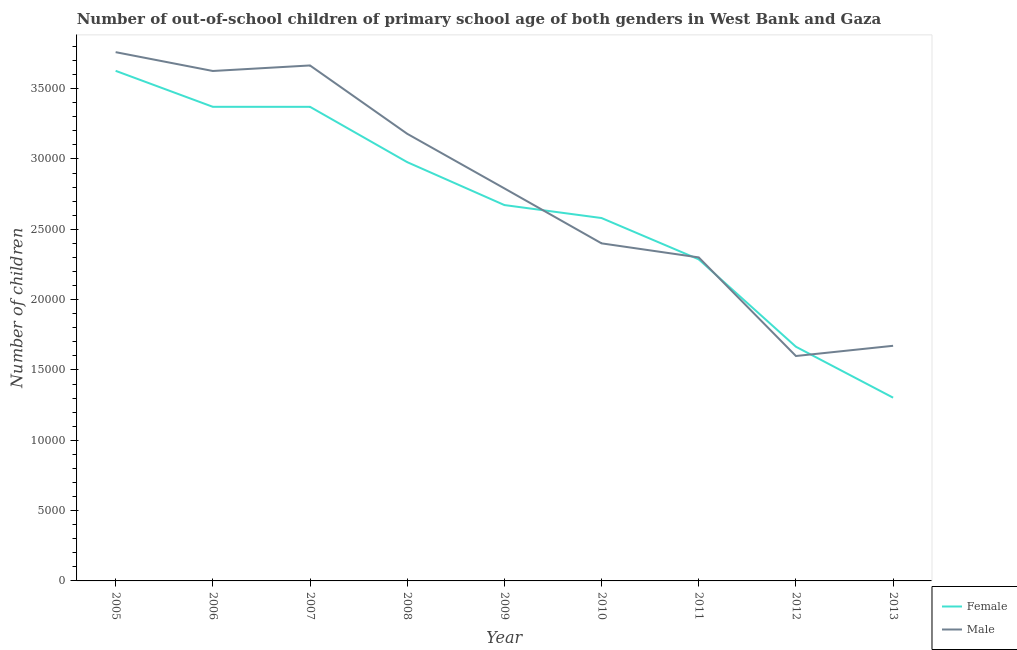How many different coloured lines are there?
Offer a very short reply. 2. Does the line corresponding to number of female out-of-school students intersect with the line corresponding to number of male out-of-school students?
Make the answer very short. Yes. Is the number of lines equal to the number of legend labels?
Provide a succinct answer. Yes. What is the number of female out-of-school students in 2006?
Provide a succinct answer. 3.37e+04. Across all years, what is the maximum number of male out-of-school students?
Give a very brief answer. 3.76e+04. Across all years, what is the minimum number of female out-of-school students?
Offer a terse response. 1.30e+04. In which year was the number of male out-of-school students minimum?
Ensure brevity in your answer.  2012. What is the total number of female out-of-school students in the graph?
Your answer should be very brief. 2.39e+05. What is the difference between the number of female out-of-school students in 2011 and that in 2013?
Provide a succinct answer. 9834. What is the difference between the number of female out-of-school students in 2006 and the number of male out-of-school students in 2013?
Ensure brevity in your answer.  1.70e+04. What is the average number of male out-of-school students per year?
Offer a terse response. 2.78e+04. In the year 2013, what is the difference between the number of female out-of-school students and number of male out-of-school students?
Offer a terse response. -3689. What is the ratio of the number of female out-of-school students in 2006 to that in 2010?
Provide a short and direct response. 1.31. Is the number of female out-of-school students in 2006 less than that in 2008?
Offer a very short reply. No. Is the difference between the number of female out-of-school students in 2007 and 2010 greater than the difference between the number of male out-of-school students in 2007 and 2010?
Give a very brief answer. No. What is the difference between the highest and the second highest number of male out-of-school students?
Keep it short and to the point. 946. What is the difference between the highest and the lowest number of male out-of-school students?
Your answer should be very brief. 2.16e+04. Is the sum of the number of female out-of-school students in 2007 and 2010 greater than the maximum number of male out-of-school students across all years?
Offer a very short reply. Yes. Does the number of female out-of-school students monotonically increase over the years?
Make the answer very short. No. How many years are there in the graph?
Your response must be concise. 9. What is the difference between two consecutive major ticks on the Y-axis?
Offer a terse response. 5000. Where does the legend appear in the graph?
Offer a terse response. Bottom right. How are the legend labels stacked?
Make the answer very short. Vertical. What is the title of the graph?
Give a very brief answer. Number of out-of-school children of primary school age of both genders in West Bank and Gaza. What is the label or title of the X-axis?
Give a very brief answer. Year. What is the label or title of the Y-axis?
Ensure brevity in your answer.  Number of children. What is the Number of children in Female in 2005?
Make the answer very short. 3.63e+04. What is the Number of children of Male in 2005?
Offer a very short reply. 3.76e+04. What is the Number of children of Female in 2006?
Keep it short and to the point. 3.37e+04. What is the Number of children in Male in 2006?
Ensure brevity in your answer.  3.63e+04. What is the Number of children in Female in 2007?
Make the answer very short. 3.37e+04. What is the Number of children in Male in 2007?
Provide a succinct answer. 3.66e+04. What is the Number of children in Female in 2008?
Your response must be concise. 2.98e+04. What is the Number of children of Male in 2008?
Provide a succinct answer. 3.18e+04. What is the Number of children of Female in 2009?
Your answer should be very brief. 2.67e+04. What is the Number of children in Male in 2009?
Offer a terse response. 2.79e+04. What is the Number of children in Female in 2010?
Your answer should be very brief. 2.58e+04. What is the Number of children of Male in 2010?
Keep it short and to the point. 2.40e+04. What is the Number of children of Female in 2011?
Your answer should be very brief. 2.29e+04. What is the Number of children in Male in 2011?
Ensure brevity in your answer.  2.30e+04. What is the Number of children of Female in 2012?
Your answer should be very brief. 1.66e+04. What is the Number of children in Male in 2012?
Provide a succinct answer. 1.60e+04. What is the Number of children of Female in 2013?
Your answer should be very brief. 1.30e+04. What is the Number of children in Male in 2013?
Offer a very short reply. 1.67e+04. Across all years, what is the maximum Number of children of Female?
Give a very brief answer. 3.63e+04. Across all years, what is the maximum Number of children of Male?
Provide a succinct answer. 3.76e+04. Across all years, what is the minimum Number of children in Female?
Offer a terse response. 1.30e+04. Across all years, what is the minimum Number of children of Male?
Offer a terse response. 1.60e+04. What is the total Number of children of Female in the graph?
Offer a terse response. 2.39e+05. What is the total Number of children of Male in the graph?
Provide a short and direct response. 2.50e+05. What is the difference between the Number of children in Female in 2005 and that in 2006?
Offer a very short reply. 2558. What is the difference between the Number of children of Male in 2005 and that in 2006?
Keep it short and to the point. 1339. What is the difference between the Number of children of Female in 2005 and that in 2007?
Provide a short and direct response. 2559. What is the difference between the Number of children in Male in 2005 and that in 2007?
Offer a terse response. 946. What is the difference between the Number of children in Female in 2005 and that in 2008?
Give a very brief answer. 6491. What is the difference between the Number of children in Male in 2005 and that in 2008?
Provide a short and direct response. 5803. What is the difference between the Number of children in Female in 2005 and that in 2009?
Keep it short and to the point. 9543. What is the difference between the Number of children in Male in 2005 and that in 2009?
Make the answer very short. 9686. What is the difference between the Number of children of Female in 2005 and that in 2010?
Provide a short and direct response. 1.05e+04. What is the difference between the Number of children in Male in 2005 and that in 2010?
Give a very brief answer. 1.36e+04. What is the difference between the Number of children of Female in 2005 and that in 2011?
Your response must be concise. 1.34e+04. What is the difference between the Number of children in Male in 2005 and that in 2011?
Make the answer very short. 1.46e+04. What is the difference between the Number of children in Female in 2005 and that in 2012?
Provide a short and direct response. 1.96e+04. What is the difference between the Number of children in Male in 2005 and that in 2012?
Provide a short and direct response. 2.16e+04. What is the difference between the Number of children in Female in 2005 and that in 2013?
Keep it short and to the point. 2.32e+04. What is the difference between the Number of children of Male in 2005 and that in 2013?
Ensure brevity in your answer.  2.09e+04. What is the difference between the Number of children of Male in 2006 and that in 2007?
Provide a succinct answer. -393. What is the difference between the Number of children of Female in 2006 and that in 2008?
Offer a terse response. 3933. What is the difference between the Number of children of Male in 2006 and that in 2008?
Your answer should be very brief. 4464. What is the difference between the Number of children of Female in 2006 and that in 2009?
Your response must be concise. 6985. What is the difference between the Number of children of Male in 2006 and that in 2009?
Provide a succinct answer. 8347. What is the difference between the Number of children of Female in 2006 and that in 2010?
Offer a terse response. 7908. What is the difference between the Number of children in Male in 2006 and that in 2010?
Your answer should be very brief. 1.23e+04. What is the difference between the Number of children of Female in 2006 and that in 2011?
Make the answer very short. 1.08e+04. What is the difference between the Number of children in Male in 2006 and that in 2011?
Offer a very short reply. 1.33e+04. What is the difference between the Number of children in Female in 2006 and that in 2012?
Keep it short and to the point. 1.71e+04. What is the difference between the Number of children of Male in 2006 and that in 2012?
Ensure brevity in your answer.  2.03e+04. What is the difference between the Number of children in Female in 2006 and that in 2013?
Ensure brevity in your answer.  2.07e+04. What is the difference between the Number of children of Male in 2006 and that in 2013?
Provide a succinct answer. 1.95e+04. What is the difference between the Number of children in Female in 2007 and that in 2008?
Ensure brevity in your answer.  3932. What is the difference between the Number of children of Male in 2007 and that in 2008?
Your answer should be very brief. 4857. What is the difference between the Number of children of Female in 2007 and that in 2009?
Give a very brief answer. 6984. What is the difference between the Number of children in Male in 2007 and that in 2009?
Your answer should be very brief. 8740. What is the difference between the Number of children in Female in 2007 and that in 2010?
Offer a very short reply. 7907. What is the difference between the Number of children in Male in 2007 and that in 2010?
Keep it short and to the point. 1.26e+04. What is the difference between the Number of children of Female in 2007 and that in 2011?
Your response must be concise. 1.08e+04. What is the difference between the Number of children in Male in 2007 and that in 2011?
Provide a succinct answer. 1.36e+04. What is the difference between the Number of children of Female in 2007 and that in 2012?
Provide a short and direct response. 1.71e+04. What is the difference between the Number of children in Male in 2007 and that in 2012?
Your answer should be very brief. 2.07e+04. What is the difference between the Number of children of Female in 2007 and that in 2013?
Give a very brief answer. 2.07e+04. What is the difference between the Number of children in Male in 2007 and that in 2013?
Your answer should be compact. 1.99e+04. What is the difference between the Number of children in Female in 2008 and that in 2009?
Provide a short and direct response. 3052. What is the difference between the Number of children in Male in 2008 and that in 2009?
Ensure brevity in your answer.  3883. What is the difference between the Number of children in Female in 2008 and that in 2010?
Give a very brief answer. 3975. What is the difference between the Number of children of Male in 2008 and that in 2010?
Your response must be concise. 7791. What is the difference between the Number of children in Female in 2008 and that in 2011?
Your answer should be very brief. 6912. What is the difference between the Number of children of Male in 2008 and that in 2011?
Your answer should be very brief. 8790. What is the difference between the Number of children in Female in 2008 and that in 2012?
Provide a succinct answer. 1.31e+04. What is the difference between the Number of children in Male in 2008 and that in 2012?
Make the answer very short. 1.58e+04. What is the difference between the Number of children of Female in 2008 and that in 2013?
Give a very brief answer. 1.67e+04. What is the difference between the Number of children of Male in 2008 and that in 2013?
Ensure brevity in your answer.  1.51e+04. What is the difference between the Number of children in Female in 2009 and that in 2010?
Your answer should be compact. 923. What is the difference between the Number of children in Male in 2009 and that in 2010?
Keep it short and to the point. 3908. What is the difference between the Number of children in Female in 2009 and that in 2011?
Offer a terse response. 3860. What is the difference between the Number of children of Male in 2009 and that in 2011?
Provide a short and direct response. 4907. What is the difference between the Number of children in Female in 2009 and that in 2012?
Offer a very short reply. 1.01e+04. What is the difference between the Number of children of Male in 2009 and that in 2012?
Ensure brevity in your answer.  1.19e+04. What is the difference between the Number of children in Female in 2009 and that in 2013?
Provide a succinct answer. 1.37e+04. What is the difference between the Number of children in Male in 2009 and that in 2013?
Provide a short and direct response. 1.12e+04. What is the difference between the Number of children of Female in 2010 and that in 2011?
Provide a short and direct response. 2937. What is the difference between the Number of children of Male in 2010 and that in 2011?
Provide a succinct answer. 999. What is the difference between the Number of children in Female in 2010 and that in 2012?
Provide a short and direct response. 9150. What is the difference between the Number of children of Male in 2010 and that in 2012?
Your response must be concise. 8009. What is the difference between the Number of children in Female in 2010 and that in 2013?
Give a very brief answer. 1.28e+04. What is the difference between the Number of children in Male in 2010 and that in 2013?
Offer a terse response. 7282. What is the difference between the Number of children in Female in 2011 and that in 2012?
Ensure brevity in your answer.  6213. What is the difference between the Number of children in Male in 2011 and that in 2012?
Ensure brevity in your answer.  7010. What is the difference between the Number of children in Female in 2011 and that in 2013?
Offer a very short reply. 9834. What is the difference between the Number of children in Male in 2011 and that in 2013?
Ensure brevity in your answer.  6283. What is the difference between the Number of children in Female in 2012 and that in 2013?
Your response must be concise. 3621. What is the difference between the Number of children in Male in 2012 and that in 2013?
Your answer should be very brief. -727. What is the difference between the Number of children in Female in 2005 and the Number of children in Male in 2006?
Keep it short and to the point. 11. What is the difference between the Number of children of Female in 2005 and the Number of children of Male in 2007?
Provide a succinct answer. -382. What is the difference between the Number of children in Female in 2005 and the Number of children in Male in 2008?
Your answer should be very brief. 4475. What is the difference between the Number of children of Female in 2005 and the Number of children of Male in 2009?
Offer a very short reply. 8358. What is the difference between the Number of children in Female in 2005 and the Number of children in Male in 2010?
Ensure brevity in your answer.  1.23e+04. What is the difference between the Number of children in Female in 2005 and the Number of children in Male in 2011?
Make the answer very short. 1.33e+04. What is the difference between the Number of children in Female in 2005 and the Number of children in Male in 2012?
Ensure brevity in your answer.  2.03e+04. What is the difference between the Number of children in Female in 2005 and the Number of children in Male in 2013?
Give a very brief answer. 1.95e+04. What is the difference between the Number of children in Female in 2006 and the Number of children in Male in 2007?
Your response must be concise. -2940. What is the difference between the Number of children of Female in 2006 and the Number of children of Male in 2008?
Your response must be concise. 1917. What is the difference between the Number of children of Female in 2006 and the Number of children of Male in 2009?
Offer a very short reply. 5800. What is the difference between the Number of children in Female in 2006 and the Number of children in Male in 2010?
Make the answer very short. 9708. What is the difference between the Number of children in Female in 2006 and the Number of children in Male in 2011?
Offer a terse response. 1.07e+04. What is the difference between the Number of children of Female in 2006 and the Number of children of Male in 2012?
Your answer should be compact. 1.77e+04. What is the difference between the Number of children in Female in 2006 and the Number of children in Male in 2013?
Keep it short and to the point. 1.70e+04. What is the difference between the Number of children in Female in 2007 and the Number of children in Male in 2008?
Keep it short and to the point. 1916. What is the difference between the Number of children in Female in 2007 and the Number of children in Male in 2009?
Offer a very short reply. 5799. What is the difference between the Number of children in Female in 2007 and the Number of children in Male in 2010?
Offer a terse response. 9707. What is the difference between the Number of children in Female in 2007 and the Number of children in Male in 2011?
Make the answer very short. 1.07e+04. What is the difference between the Number of children of Female in 2007 and the Number of children of Male in 2012?
Provide a succinct answer. 1.77e+04. What is the difference between the Number of children in Female in 2007 and the Number of children in Male in 2013?
Provide a short and direct response. 1.70e+04. What is the difference between the Number of children in Female in 2008 and the Number of children in Male in 2009?
Make the answer very short. 1867. What is the difference between the Number of children in Female in 2008 and the Number of children in Male in 2010?
Provide a short and direct response. 5775. What is the difference between the Number of children in Female in 2008 and the Number of children in Male in 2011?
Ensure brevity in your answer.  6774. What is the difference between the Number of children of Female in 2008 and the Number of children of Male in 2012?
Your answer should be very brief. 1.38e+04. What is the difference between the Number of children of Female in 2008 and the Number of children of Male in 2013?
Provide a short and direct response. 1.31e+04. What is the difference between the Number of children in Female in 2009 and the Number of children in Male in 2010?
Your answer should be compact. 2723. What is the difference between the Number of children in Female in 2009 and the Number of children in Male in 2011?
Your answer should be very brief. 3722. What is the difference between the Number of children in Female in 2009 and the Number of children in Male in 2012?
Make the answer very short. 1.07e+04. What is the difference between the Number of children in Female in 2009 and the Number of children in Male in 2013?
Keep it short and to the point. 1.00e+04. What is the difference between the Number of children in Female in 2010 and the Number of children in Male in 2011?
Make the answer very short. 2799. What is the difference between the Number of children of Female in 2010 and the Number of children of Male in 2012?
Your response must be concise. 9809. What is the difference between the Number of children in Female in 2010 and the Number of children in Male in 2013?
Make the answer very short. 9082. What is the difference between the Number of children in Female in 2011 and the Number of children in Male in 2012?
Provide a succinct answer. 6872. What is the difference between the Number of children in Female in 2011 and the Number of children in Male in 2013?
Provide a short and direct response. 6145. What is the difference between the Number of children of Female in 2012 and the Number of children of Male in 2013?
Ensure brevity in your answer.  -68. What is the average Number of children in Female per year?
Your response must be concise. 2.65e+04. What is the average Number of children in Male per year?
Your answer should be compact. 2.78e+04. In the year 2005, what is the difference between the Number of children of Female and Number of children of Male?
Your response must be concise. -1328. In the year 2006, what is the difference between the Number of children of Female and Number of children of Male?
Your answer should be compact. -2547. In the year 2007, what is the difference between the Number of children in Female and Number of children in Male?
Keep it short and to the point. -2941. In the year 2008, what is the difference between the Number of children of Female and Number of children of Male?
Offer a terse response. -2016. In the year 2009, what is the difference between the Number of children of Female and Number of children of Male?
Make the answer very short. -1185. In the year 2010, what is the difference between the Number of children in Female and Number of children in Male?
Offer a terse response. 1800. In the year 2011, what is the difference between the Number of children in Female and Number of children in Male?
Your answer should be compact. -138. In the year 2012, what is the difference between the Number of children in Female and Number of children in Male?
Offer a terse response. 659. In the year 2013, what is the difference between the Number of children in Female and Number of children in Male?
Your answer should be compact. -3689. What is the ratio of the Number of children in Female in 2005 to that in 2006?
Make the answer very short. 1.08. What is the ratio of the Number of children in Male in 2005 to that in 2006?
Your answer should be very brief. 1.04. What is the ratio of the Number of children in Female in 2005 to that in 2007?
Your answer should be compact. 1.08. What is the ratio of the Number of children in Male in 2005 to that in 2007?
Offer a terse response. 1.03. What is the ratio of the Number of children in Female in 2005 to that in 2008?
Ensure brevity in your answer.  1.22. What is the ratio of the Number of children of Male in 2005 to that in 2008?
Ensure brevity in your answer.  1.18. What is the ratio of the Number of children in Female in 2005 to that in 2009?
Your answer should be very brief. 1.36. What is the ratio of the Number of children of Male in 2005 to that in 2009?
Provide a succinct answer. 1.35. What is the ratio of the Number of children of Female in 2005 to that in 2010?
Provide a succinct answer. 1.41. What is the ratio of the Number of children of Male in 2005 to that in 2010?
Your answer should be very brief. 1.57. What is the ratio of the Number of children in Female in 2005 to that in 2011?
Your answer should be very brief. 1.59. What is the ratio of the Number of children in Male in 2005 to that in 2011?
Ensure brevity in your answer.  1.63. What is the ratio of the Number of children of Female in 2005 to that in 2012?
Keep it short and to the point. 2.18. What is the ratio of the Number of children of Male in 2005 to that in 2012?
Your response must be concise. 2.35. What is the ratio of the Number of children of Female in 2005 to that in 2013?
Your answer should be very brief. 2.78. What is the ratio of the Number of children of Male in 2005 to that in 2013?
Provide a succinct answer. 2.25. What is the ratio of the Number of children in Female in 2006 to that in 2007?
Provide a succinct answer. 1. What is the ratio of the Number of children of Male in 2006 to that in 2007?
Offer a very short reply. 0.99. What is the ratio of the Number of children of Female in 2006 to that in 2008?
Keep it short and to the point. 1.13. What is the ratio of the Number of children in Male in 2006 to that in 2008?
Offer a terse response. 1.14. What is the ratio of the Number of children of Female in 2006 to that in 2009?
Provide a succinct answer. 1.26. What is the ratio of the Number of children of Male in 2006 to that in 2009?
Your answer should be compact. 1.3. What is the ratio of the Number of children of Female in 2006 to that in 2010?
Provide a short and direct response. 1.31. What is the ratio of the Number of children of Male in 2006 to that in 2010?
Give a very brief answer. 1.51. What is the ratio of the Number of children in Female in 2006 to that in 2011?
Ensure brevity in your answer.  1.47. What is the ratio of the Number of children of Male in 2006 to that in 2011?
Provide a short and direct response. 1.58. What is the ratio of the Number of children in Female in 2006 to that in 2012?
Your response must be concise. 2.02. What is the ratio of the Number of children in Male in 2006 to that in 2012?
Offer a terse response. 2.27. What is the ratio of the Number of children of Female in 2006 to that in 2013?
Your answer should be compact. 2.59. What is the ratio of the Number of children in Male in 2006 to that in 2013?
Provide a short and direct response. 2.17. What is the ratio of the Number of children in Female in 2007 to that in 2008?
Offer a very short reply. 1.13. What is the ratio of the Number of children in Male in 2007 to that in 2008?
Ensure brevity in your answer.  1.15. What is the ratio of the Number of children in Female in 2007 to that in 2009?
Provide a short and direct response. 1.26. What is the ratio of the Number of children of Male in 2007 to that in 2009?
Ensure brevity in your answer.  1.31. What is the ratio of the Number of children in Female in 2007 to that in 2010?
Make the answer very short. 1.31. What is the ratio of the Number of children of Male in 2007 to that in 2010?
Keep it short and to the point. 1.53. What is the ratio of the Number of children of Female in 2007 to that in 2011?
Your answer should be compact. 1.47. What is the ratio of the Number of children in Male in 2007 to that in 2011?
Offer a terse response. 1.59. What is the ratio of the Number of children in Female in 2007 to that in 2012?
Offer a terse response. 2.02. What is the ratio of the Number of children of Male in 2007 to that in 2012?
Provide a short and direct response. 2.29. What is the ratio of the Number of children in Female in 2007 to that in 2013?
Your answer should be compact. 2.59. What is the ratio of the Number of children of Male in 2007 to that in 2013?
Provide a short and direct response. 2.19. What is the ratio of the Number of children of Female in 2008 to that in 2009?
Keep it short and to the point. 1.11. What is the ratio of the Number of children in Male in 2008 to that in 2009?
Your response must be concise. 1.14. What is the ratio of the Number of children in Female in 2008 to that in 2010?
Give a very brief answer. 1.15. What is the ratio of the Number of children in Male in 2008 to that in 2010?
Offer a terse response. 1.32. What is the ratio of the Number of children in Female in 2008 to that in 2011?
Your response must be concise. 1.3. What is the ratio of the Number of children in Male in 2008 to that in 2011?
Offer a very short reply. 1.38. What is the ratio of the Number of children in Female in 2008 to that in 2012?
Provide a succinct answer. 1.79. What is the ratio of the Number of children of Male in 2008 to that in 2012?
Your response must be concise. 1.99. What is the ratio of the Number of children of Female in 2008 to that in 2013?
Your answer should be compact. 2.29. What is the ratio of the Number of children of Male in 2008 to that in 2013?
Provide a short and direct response. 1.9. What is the ratio of the Number of children in Female in 2009 to that in 2010?
Your response must be concise. 1.04. What is the ratio of the Number of children of Male in 2009 to that in 2010?
Keep it short and to the point. 1.16. What is the ratio of the Number of children of Female in 2009 to that in 2011?
Your answer should be compact. 1.17. What is the ratio of the Number of children of Male in 2009 to that in 2011?
Provide a succinct answer. 1.21. What is the ratio of the Number of children in Female in 2009 to that in 2012?
Offer a terse response. 1.6. What is the ratio of the Number of children of Male in 2009 to that in 2012?
Keep it short and to the point. 1.75. What is the ratio of the Number of children of Female in 2009 to that in 2013?
Offer a terse response. 2.05. What is the ratio of the Number of children of Male in 2009 to that in 2013?
Offer a very short reply. 1.67. What is the ratio of the Number of children of Female in 2010 to that in 2011?
Offer a very short reply. 1.13. What is the ratio of the Number of children of Male in 2010 to that in 2011?
Keep it short and to the point. 1.04. What is the ratio of the Number of children in Female in 2010 to that in 2012?
Make the answer very short. 1.55. What is the ratio of the Number of children in Male in 2010 to that in 2012?
Ensure brevity in your answer.  1.5. What is the ratio of the Number of children in Female in 2010 to that in 2013?
Offer a terse response. 1.98. What is the ratio of the Number of children of Male in 2010 to that in 2013?
Offer a very short reply. 1.44. What is the ratio of the Number of children of Female in 2011 to that in 2012?
Ensure brevity in your answer.  1.37. What is the ratio of the Number of children of Male in 2011 to that in 2012?
Give a very brief answer. 1.44. What is the ratio of the Number of children of Female in 2011 to that in 2013?
Provide a short and direct response. 1.75. What is the ratio of the Number of children in Male in 2011 to that in 2013?
Ensure brevity in your answer.  1.38. What is the ratio of the Number of children in Female in 2012 to that in 2013?
Offer a terse response. 1.28. What is the ratio of the Number of children of Male in 2012 to that in 2013?
Ensure brevity in your answer.  0.96. What is the difference between the highest and the second highest Number of children in Female?
Provide a succinct answer. 2558. What is the difference between the highest and the second highest Number of children of Male?
Your answer should be very brief. 946. What is the difference between the highest and the lowest Number of children of Female?
Your answer should be compact. 2.32e+04. What is the difference between the highest and the lowest Number of children in Male?
Make the answer very short. 2.16e+04. 